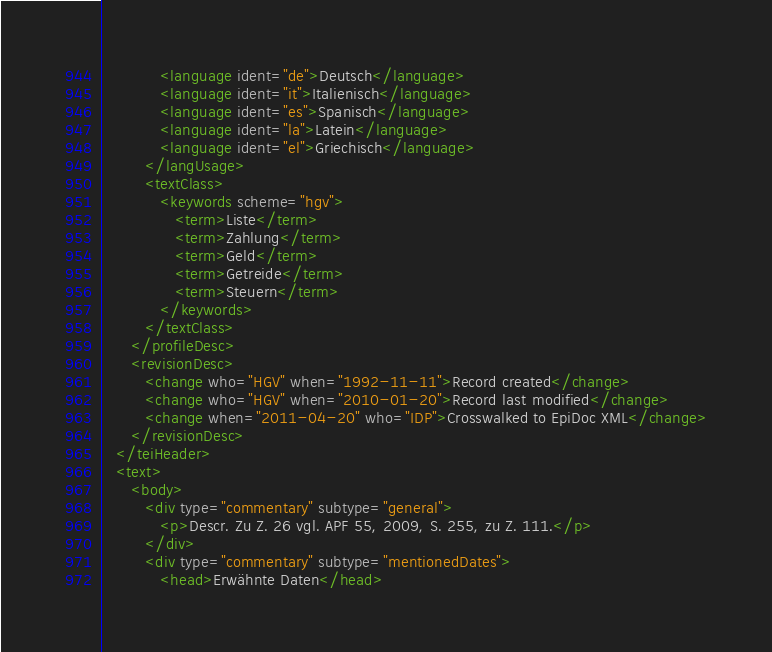Convert code to text. <code><loc_0><loc_0><loc_500><loc_500><_XML_>            <language ident="de">Deutsch</language>
            <language ident="it">Italienisch</language>
            <language ident="es">Spanisch</language>
            <language ident="la">Latein</language>
            <language ident="el">Griechisch</language>
         </langUsage>
         <textClass>
            <keywords scheme="hgv">
               <term>Liste</term>
               <term>Zahlung</term>
               <term>Geld</term>
               <term>Getreide</term>
               <term>Steuern</term>
            </keywords>
         </textClass>
      </profileDesc>
      <revisionDesc>
         <change who="HGV" when="1992-11-11">Record created</change>
         <change who="HGV" when="2010-01-20">Record last modified</change>
         <change when="2011-04-20" who="IDP">Crosswalked to EpiDoc XML</change>
      </revisionDesc>
   </teiHeader>
   <text>
      <body>
         <div type="commentary" subtype="general">
            <p>Descr. Zu Z. 26 vgl. APF 55, 2009, S. 255, zu Z. 111.</p>
         </div>
         <div type="commentary" subtype="mentionedDates">
            <head>Erwähnte Daten</head></code> 